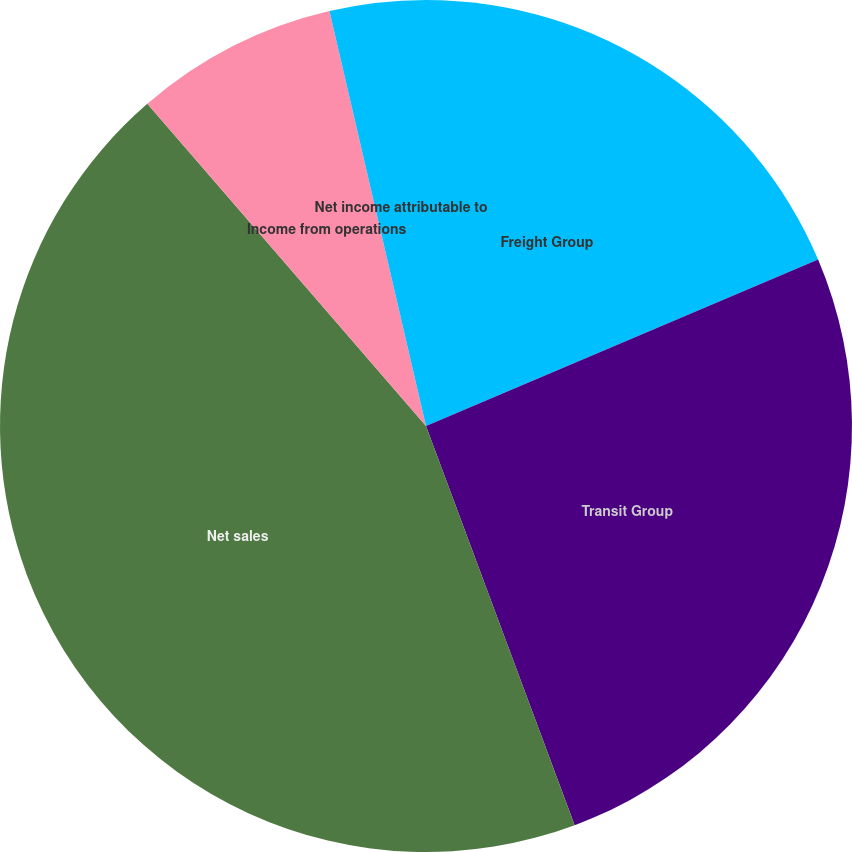Convert chart to OTSL. <chart><loc_0><loc_0><loc_500><loc_500><pie_chart><fcel>Freight Group<fcel>Transit Group<fcel>Net sales<fcel>Income from operations<fcel>Net income attributable to<nl><fcel>18.61%<fcel>25.72%<fcel>44.33%<fcel>7.71%<fcel>3.64%<nl></chart> 